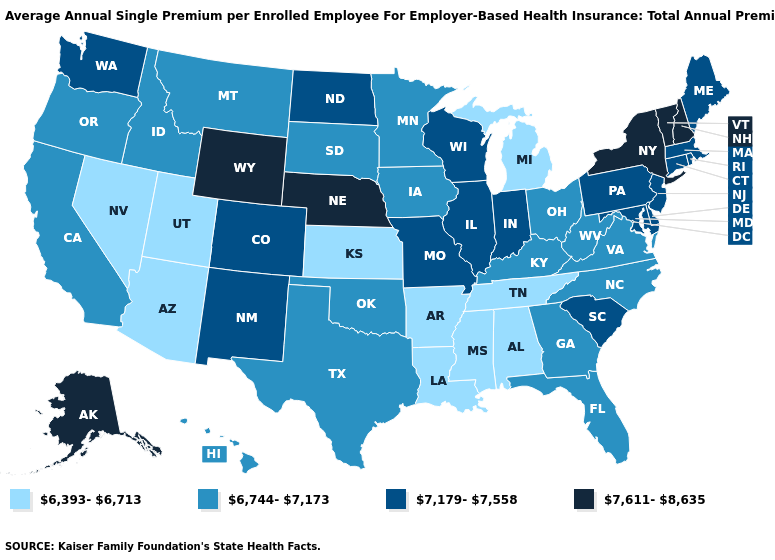Among the states that border Minnesota , which have the highest value?
Concise answer only. North Dakota, Wisconsin. Which states have the lowest value in the USA?
Short answer required. Alabama, Arizona, Arkansas, Kansas, Louisiana, Michigan, Mississippi, Nevada, Tennessee, Utah. What is the value of South Carolina?
Short answer required. 7,179-7,558. Name the states that have a value in the range 6,744-7,173?
Keep it brief. California, Florida, Georgia, Hawaii, Idaho, Iowa, Kentucky, Minnesota, Montana, North Carolina, Ohio, Oklahoma, Oregon, South Dakota, Texas, Virginia, West Virginia. Name the states that have a value in the range 7,611-8,635?
Write a very short answer. Alaska, Nebraska, New Hampshire, New York, Vermont, Wyoming. What is the value of Minnesota?
Answer briefly. 6,744-7,173. Among the states that border New Jersey , does New York have the lowest value?
Quick response, please. No. Does Wyoming have a higher value than California?
Give a very brief answer. Yes. Name the states that have a value in the range 6,744-7,173?
Concise answer only. California, Florida, Georgia, Hawaii, Idaho, Iowa, Kentucky, Minnesota, Montana, North Carolina, Ohio, Oklahoma, Oregon, South Dakota, Texas, Virginia, West Virginia. Does Maryland have the highest value in the South?
Answer briefly. Yes. What is the value of Kentucky?
Give a very brief answer. 6,744-7,173. Name the states that have a value in the range 6,393-6,713?
Quick response, please. Alabama, Arizona, Arkansas, Kansas, Louisiana, Michigan, Mississippi, Nevada, Tennessee, Utah. Which states have the lowest value in the Northeast?
Give a very brief answer. Connecticut, Maine, Massachusetts, New Jersey, Pennsylvania, Rhode Island. Name the states that have a value in the range 6,744-7,173?
Write a very short answer. California, Florida, Georgia, Hawaii, Idaho, Iowa, Kentucky, Minnesota, Montana, North Carolina, Ohio, Oklahoma, Oregon, South Dakota, Texas, Virginia, West Virginia. Does Arizona have a lower value than New Mexico?
Concise answer only. Yes. 